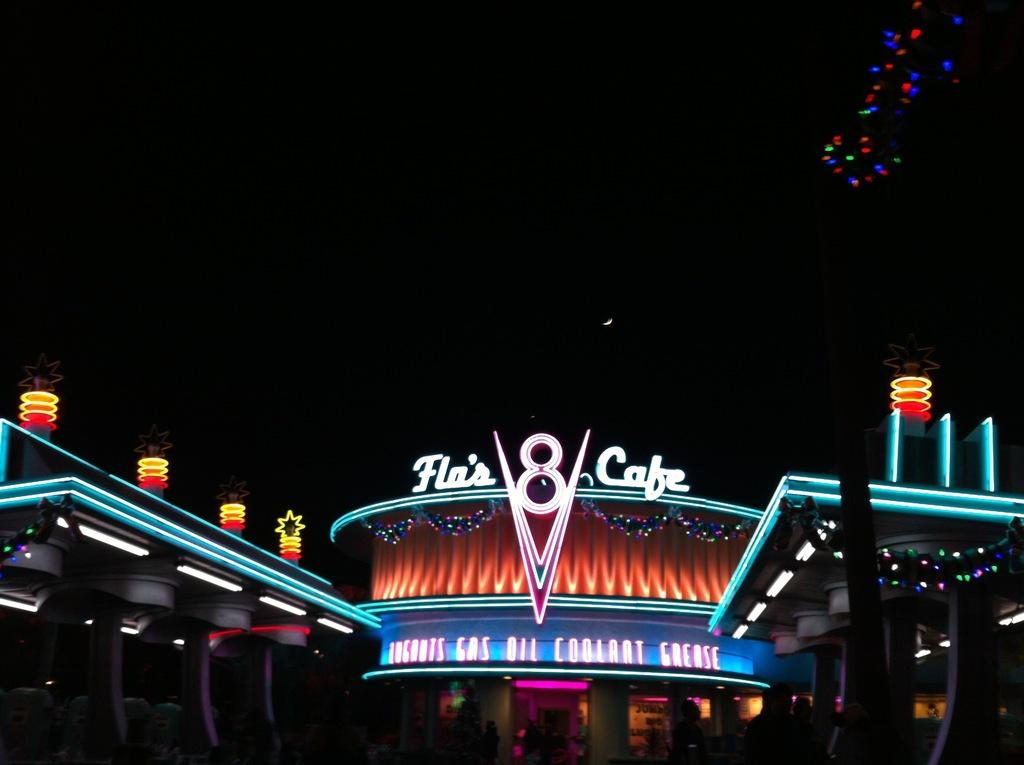What type of structure is visible in the image? There is a building in the image. What is covering the building in the image? The building has an acrylic hoarding. What is the name of the establishment on the hoarding? The hoarding is named 'flos 8 cafe'. What type of stew is being served at the cafe in the image? There is no indication of any food or stew being served in the image; it only shows the building with the acrylic hoarding. Can you see a bucket on the roof of the building in the image? There is no mention of a bucket or any rooftop elements in the image; it only shows the building with the acrylic hoarding. 